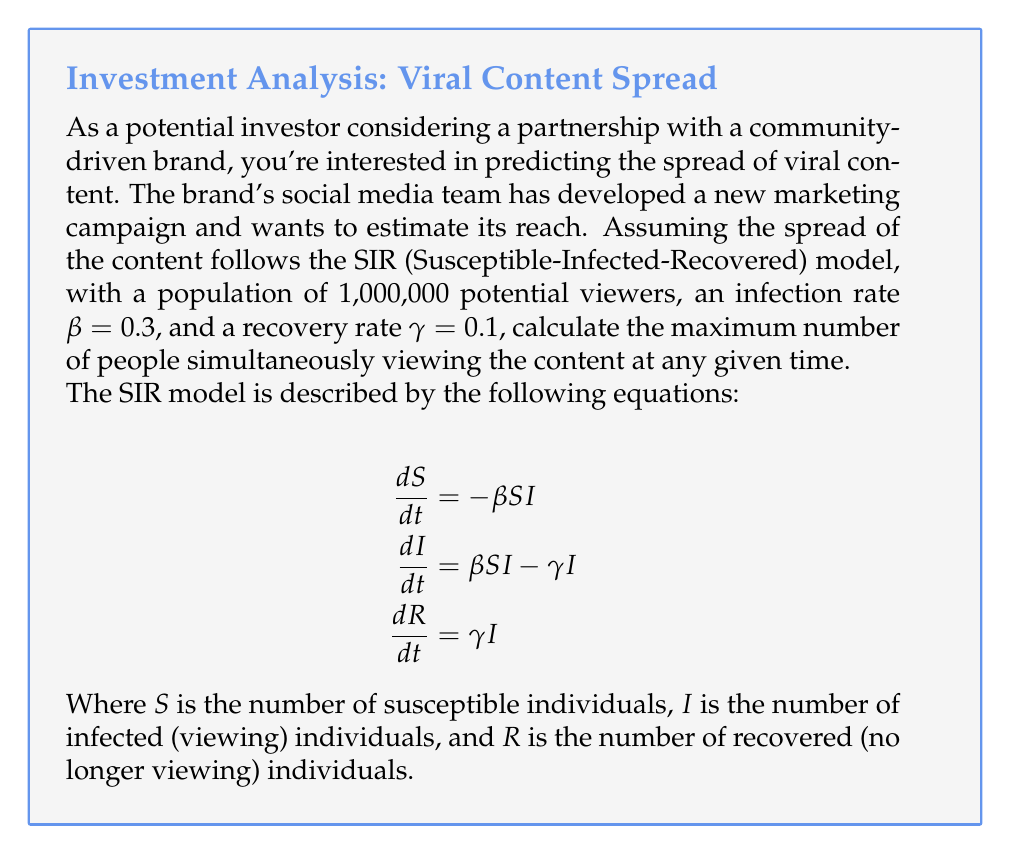Teach me how to tackle this problem. To find the maximum number of people simultaneously viewing the content, we need to determine when dI/dt = 0, which occurs at the peak of the "infection" curve. At this point:

1. Set dI/dt = 0:
   $$\beta SI - \gamma I = 0$$

2. Factor out I:
   $$I(\beta S - \gamma) = 0$$

3. Since I ≠ 0 (we're looking for the peak), solve for S:
   $$\beta S - \gamma = 0$$
   $$\beta S = \gamma$$
   $$S = \frac{\gamma}{\beta}$$

4. Substitute the given values:
   $$S = \frac{0.1}{0.3} = \frac{1}{3}$$

5. This means that at the peak, one-third of the population is still susceptible. We can use the conservation of population to find I:

   $$N = S + I + R$$
   $$1,000,000 = \frac{1,000,000}{3} + I + R$$

6. At the start of the epidemic, R ≈ 0, so:
   $$I_{max} = 1,000,000 - \frac{1,000,000}{3} = \frac{2,000,000}{3}$$

7. Calculate the final value:
   $$I_{max} = \frac{2,000,000}{3} = 666,666.67$$

Therefore, the maximum number of people simultaneously viewing the content, rounded to the nearest whole number, is 666,667.
Answer: 666,667 viewers 